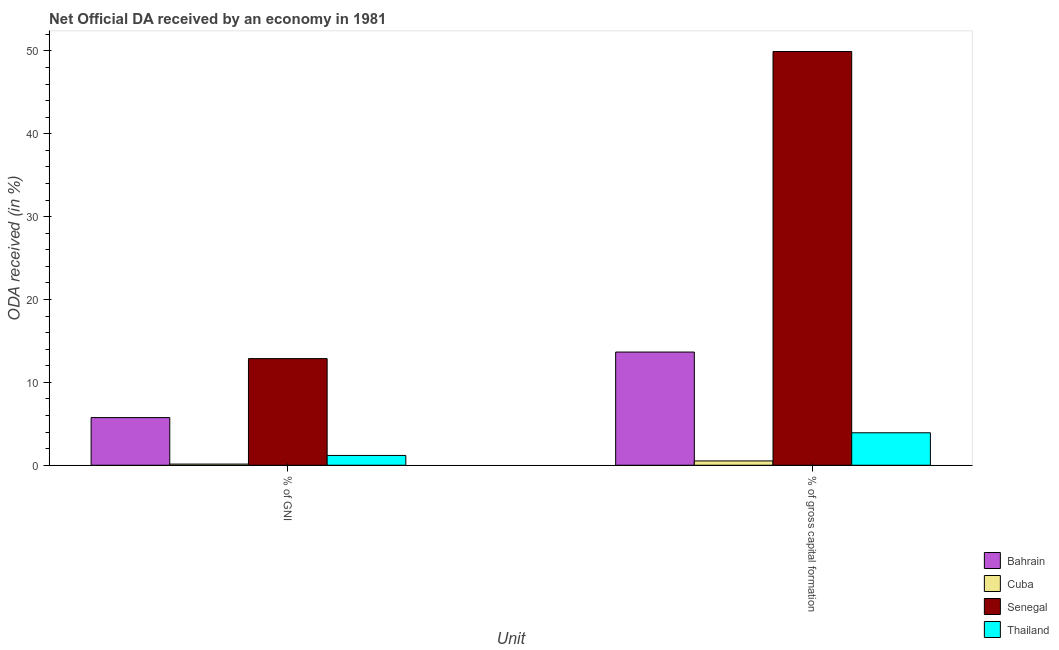How many different coloured bars are there?
Provide a succinct answer. 4. How many groups of bars are there?
Provide a short and direct response. 2. Are the number of bars per tick equal to the number of legend labels?
Ensure brevity in your answer.  Yes. Are the number of bars on each tick of the X-axis equal?
Make the answer very short. Yes. How many bars are there on the 1st tick from the left?
Make the answer very short. 4. What is the label of the 2nd group of bars from the left?
Make the answer very short. % of gross capital formation. What is the oda received as percentage of gni in Thailand?
Your response must be concise. 1.18. Across all countries, what is the maximum oda received as percentage of gni?
Make the answer very short. 12.87. Across all countries, what is the minimum oda received as percentage of gni?
Ensure brevity in your answer.  0.14. In which country was the oda received as percentage of gross capital formation maximum?
Keep it short and to the point. Senegal. In which country was the oda received as percentage of gni minimum?
Keep it short and to the point. Cuba. What is the total oda received as percentage of gross capital formation in the graph?
Your answer should be compact. 68.04. What is the difference between the oda received as percentage of gni in Bahrain and that in Cuba?
Keep it short and to the point. 5.61. What is the difference between the oda received as percentage of gni in Thailand and the oda received as percentage of gross capital formation in Senegal?
Make the answer very short. -48.76. What is the average oda received as percentage of gross capital formation per country?
Make the answer very short. 17.01. What is the difference between the oda received as percentage of gni and oda received as percentage of gross capital formation in Thailand?
Provide a short and direct response. -2.74. What is the ratio of the oda received as percentage of gross capital formation in Thailand to that in Bahrain?
Provide a succinct answer. 0.29. In how many countries, is the oda received as percentage of gni greater than the average oda received as percentage of gni taken over all countries?
Make the answer very short. 2. What does the 1st bar from the left in % of gross capital formation represents?
Keep it short and to the point. Bahrain. What does the 2nd bar from the right in % of gross capital formation represents?
Provide a succinct answer. Senegal. How many bars are there?
Provide a short and direct response. 8. Are all the bars in the graph horizontal?
Offer a terse response. No. How many countries are there in the graph?
Keep it short and to the point. 4. What is the difference between two consecutive major ticks on the Y-axis?
Provide a short and direct response. 10. Does the graph contain any zero values?
Make the answer very short. No. What is the title of the graph?
Your answer should be compact. Net Official DA received by an economy in 1981. Does "East Asia (developing only)" appear as one of the legend labels in the graph?
Make the answer very short. No. What is the label or title of the X-axis?
Give a very brief answer. Unit. What is the label or title of the Y-axis?
Provide a short and direct response. ODA received (in %). What is the ODA received (in %) in Bahrain in % of GNI?
Provide a short and direct response. 5.75. What is the ODA received (in %) of Cuba in % of GNI?
Offer a very short reply. 0.14. What is the ODA received (in %) of Senegal in % of GNI?
Provide a succinct answer. 12.87. What is the ODA received (in %) in Thailand in % of GNI?
Provide a short and direct response. 1.18. What is the ODA received (in %) of Bahrain in % of gross capital formation?
Your answer should be compact. 13.66. What is the ODA received (in %) in Cuba in % of gross capital formation?
Ensure brevity in your answer.  0.52. What is the ODA received (in %) in Senegal in % of gross capital formation?
Your answer should be very brief. 49.94. What is the ODA received (in %) in Thailand in % of gross capital formation?
Your answer should be very brief. 3.92. Across all Unit, what is the maximum ODA received (in %) in Bahrain?
Ensure brevity in your answer.  13.66. Across all Unit, what is the maximum ODA received (in %) in Cuba?
Your answer should be compact. 0.52. Across all Unit, what is the maximum ODA received (in %) of Senegal?
Provide a short and direct response. 49.94. Across all Unit, what is the maximum ODA received (in %) of Thailand?
Offer a terse response. 3.92. Across all Unit, what is the minimum ODA received (in %) of Bahrain?
Make the answer very short. 5.75. Across all Unit, what is the minimum ODA received (in %) in Cuba?
Keep it short and to the point. 0.14. Across all Unit, what is the minimum ODA received (in %) in Senegal?
Provide a succinct answer. 12.87. Across all Unit, what is the minimum ODA received (in %) of Thailand?
Your answer should be very brief. 1.18. What is the total ODA received (in %) in Bahrain in the graph?
Keep it short and to the point. 19.41. What is the total ODA received (in %) of Cuba in the graph?
Your answer should be very brief. 0.66. What is the total ODA received (in %) of Senegal in the graph?
Make the answer very short. 62.81. What is the total ODA received (in %) of Thailand in the graph?
Provide a succinct answer. 5.1. What is the difference between the ODA received (in %) in Bahrain in % of GNI and that in % of gross capital formation?
Ensure brevity in your answer.  -7.91. What is the difference between the ODA received (in %) in Cuba in % of GNI and that in % of gross capital formation?
Offer a terse response. -0.38. What is the difference between the ODA received (in %) in Senegal in % of GNI and that in % of gross capital formation?
Keep it short and to the point. -37.07. What is the difference between the ODA received (in %) in Thailand in % of GNI and that in % of gross capital formation?
Ensure brevity in your answer.  -2.74. What is the difference between the ODA received (in %) in Bahrain in % of GNI and the ODA received (in %) in Cuba in % of gross capital formation?
Offer a very short reply. 5.23. What is the difference between the ODA received (in %) of Bahrain in % of GNI and the ODA received (in %) of Senegal in % of gross capital formation?
Give a very brief answer. -44.19. What is the difference between the ODA received (in %) in Bahrain in % of GNI and the ODA received (in %) in Thailand in % of gross capital formation?
Your response must be concise. 1.83. What is the difference between the ODA received (in %) of Cuba in % of GNI and the ODA received (in %) of Senegal in % of gross capital formation?
Provide a short and direct response. -49.8. What is the difference between the ODA received (in %) in Cuba in % of GNI and the ODA received (in %) in Thailand in % of gross capital formation?
Your answer should be compact. -3.78. What is the difference between the ODA received (in %) of Senegal in % of GNI and the ODA received (in %) of Thailand in % of gross capital formation?
Offer a very short reply. 8.95. What is the average ODA received (in %) of Bahrain per Unit?
Provide a succinct answer. 9.71. What is the average ODA received (in %) of Cuba per Unit?
Offer a very short reply. 0.33. What is the average ODA received (in %) in Senegal per Unit?
Provide a short and direct response. 31.41. What is the average ODA received (in %) of Thailand per Unit?
Your answer should be very brief. 2.55. What is the difference between the ODA received (in %) in Bahrain and ODA received (in %) in Cuba in % of GNI?
Your answer should be very brief. 5.61. What is the difference between the ODA received (in %) in Bahrain and ODA received (in %) in Senegal in % of GNI?
Offer a very short reply. -7.12. What is the difference between the ODA received (in %) of Bahrain and ODA received (in %) of Thailand in % of GNI?
Provide a short and direct response. 4.57. What is the difference between the ODA received (in %) in Cuba and ODA received (in %) in Senegal in % of GNI?
Provide a short and direct response. -12.73. What is the difference between the ODA received (in %) of Cuba and ODA received (in %) of Thailand in % of GNI?
Give a very brief answer. -1.04. What is the difference between the ODA received (in %) in Senegal and ODA received (in %) in Thailand in % of GNI?
Offer a terse response. 11.69. What is the difference between the ODA received (in %) of Bahrain and ODA received (in %) of Cuba in % of gross capital formation?
Provide a short and direct response. 13.14. What is the difference between the ODA received (in %) in Bahrain and ODA received (in %) in Senegal in % of gross capital formation?
Your answer should be compact. -36.28. What is the difference between the ODA received (in %) of Bahrain and ODA received (in %) of Thailand in % of gross capital formation?
Your response must be concise. 9.74. What is the difference between the ODA received (in %) in Cuba and ODA received (in %) in Senegal in % of gross capital formation?
Provide a succinct answer. -49.42. What is the difference between the ODA received (in %) of Cuba and ODA received (in %) of Thailand in % of gross capital formation?
Ensure brevity in your answer.  -3.4. What is the difference between the ODA received (in %) of Senegal and ODA received (in %) of Thailand in % of gross capital formation?
Your answer should be very brief. 46.02. What is the ratio of the ODA received (in %) of Bahrain in % of GNI to that in % of gross capital formation?
Your answer should be compact. 0.42. What is the ratio of the ODA received (in %) of Cuba in % of GNI to that in % of gross capital formation?
Keep it short and to the point. 0.27. What is the ratio of the ODA received (in %) in Senegal in % of GNI to that in % of gross capital formation?
Provide a short and direct response. 0.26. What is the ratio of the ODA received (in %) of Thailand in % of GNI to that in % of gross capital formation?
Your answer should be very brief. 0.3. What is the difference between the highest and the second highest ODA received (in %) of Bahrain?
Offer a very short reply. 7.91. What is the difference between the highest and the second highest ODA received (in %) of Cuba?
Ensure brevity in your answer.  0.38. What is the difference between the highest and the second highest ODA received (in %) of Senegal?
Your answer should be compact. 37.07. What is the difference between the highest and the second highest ODA received (in %) in Thailand?
Your answer should be very brief. 2.74. What is the difference between the highest and the lowest ODA received (in %) in Bahrain?
Offer a very short reply. 7.91. What is the difference between the highest and the lowest ODA received (in %) of Cuba?
Ensure brevity in your answer.  0.38. What is the difference between the highest and the lowest ODA received (in %) in Senegal?
Your answer should be very brief. 37.07. What is the difference between the highest and the lowest ODA received (in %) of Thailand?
Provide a short and direct response. 2.74. 